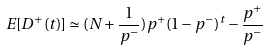Convert formula to latex. <formula><loc_0><loc_0><loc_500><loc_500>E [ D ^ { + } ( t ) ] \simeq ( N + \frac { 1 } { p ^ { - } } ) p ^ { + } ( 1 - p ^ { - } ) ^ { t } - \frac { p ^ { + } } { p ^ { - } }</formula> 